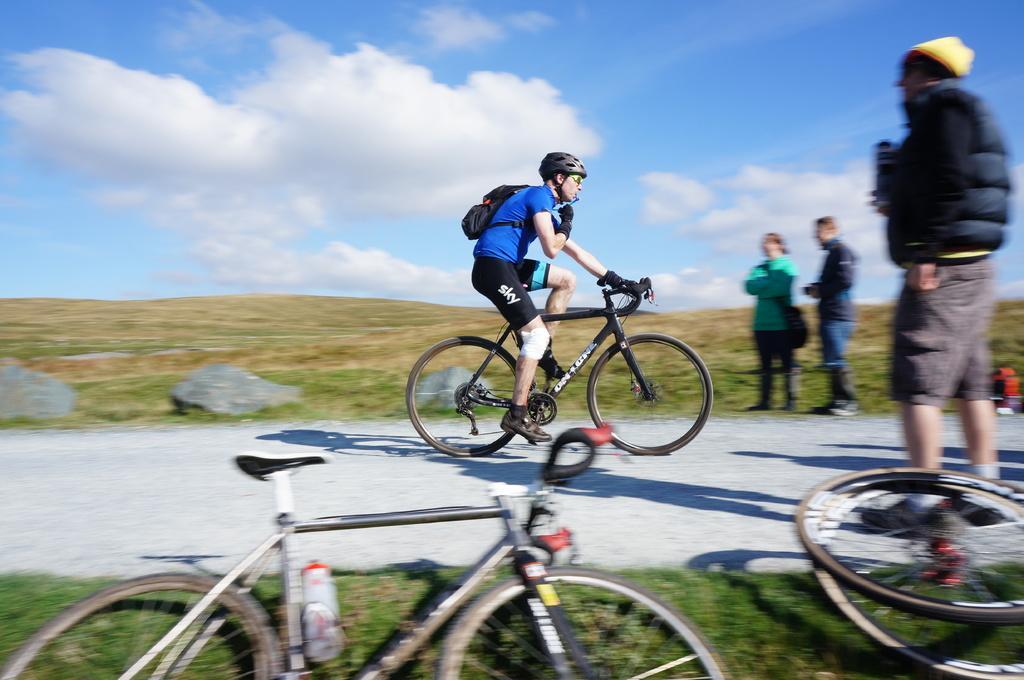Can you describe this image briefly? The person wearing blue shirt is riding bicycle and there are few people on the either side of him and there are two cycles which are laid down on the grass and the sky is a bit cloudy. 